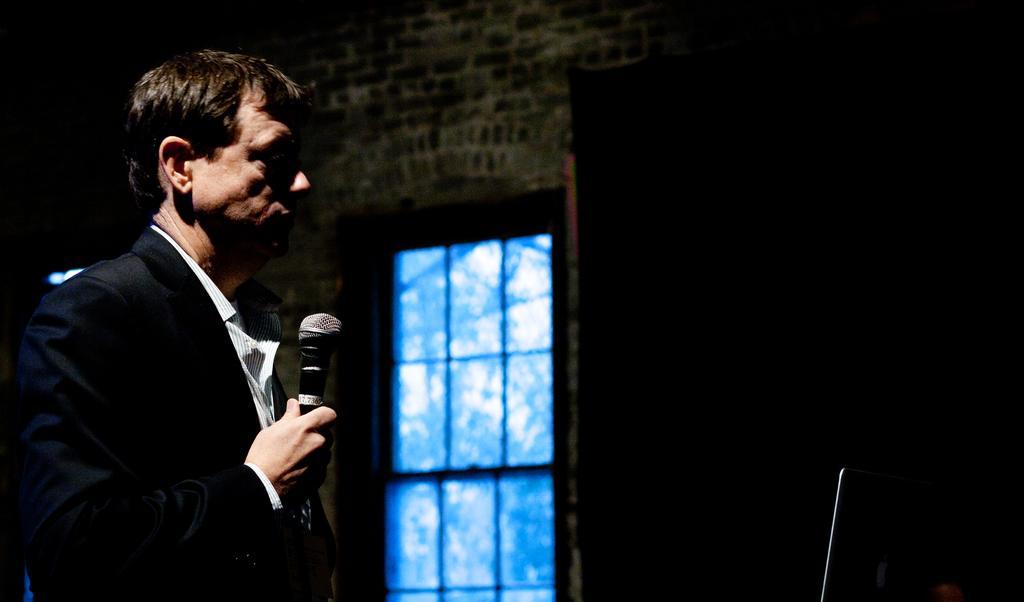Describe this image in one or two sentences. A man with black jacket and white shirt is standing and holding a mic in his hand and he is to the left. To the right side there is a monitor. In the middle there is a window. 